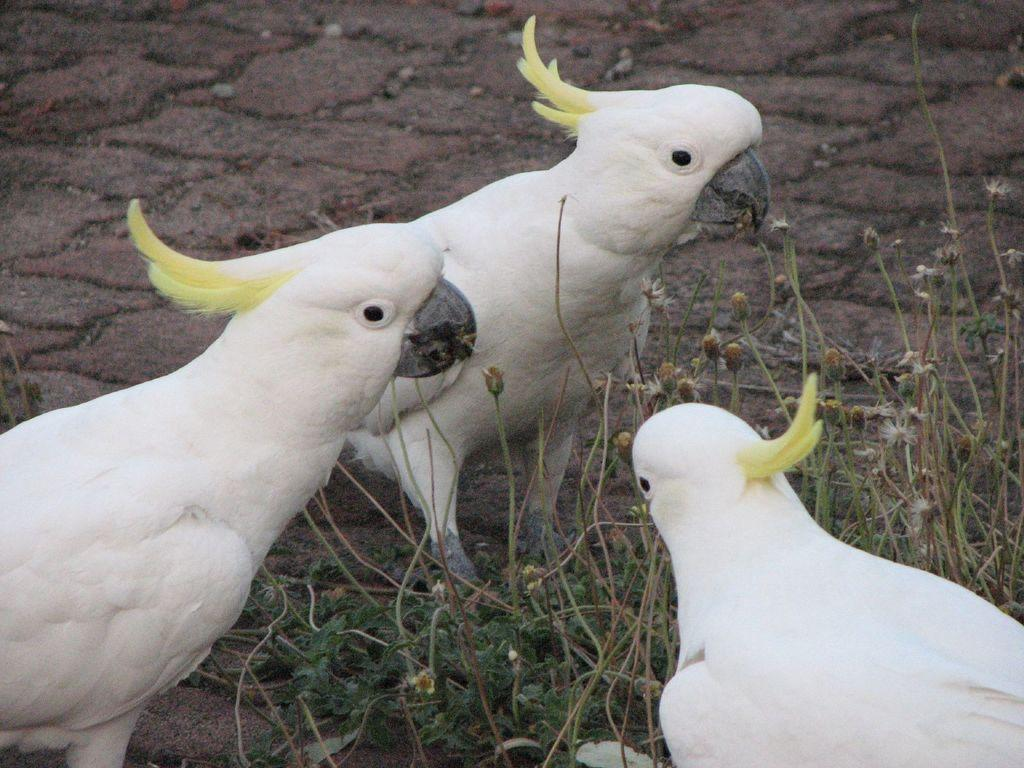What type of animals can be seen on the ground in the image? There are three white color birds on the ground in the image. What can be seen on the right side of the image? There are plants on the right side of the image. What additional feature is associated with the plants? There are flowers associated with the plants. What type of jeans is the secretary wearing in the image? There is no secretary or jeans present in the image. What action are the birds performing in the image? The provided facts do not specify any actions being performed by the birds; they are simply standing on the ground. 